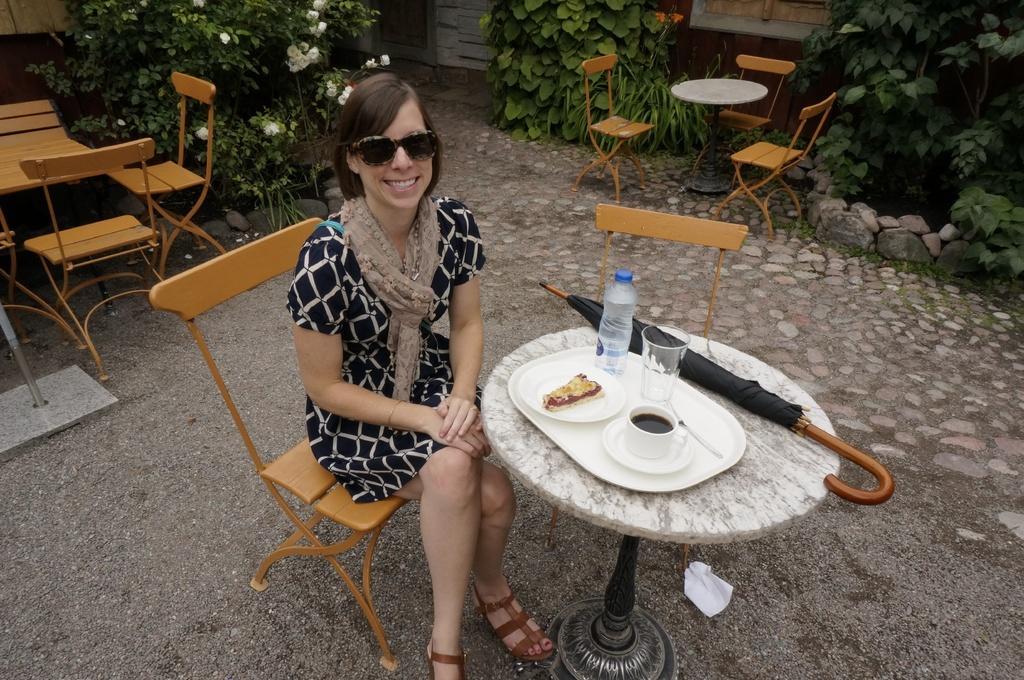In one or two sentences, can you explain what this image depicts? In this image I can see a woman wearing a black dress, scarf and sunglasses is sitting on the chair in front of a table, on the table I can see an umbrella, a bottle,a glass, a cup,few plates and a food item in it. In the background i can see few empty chairs and tables, few plants and the building. 